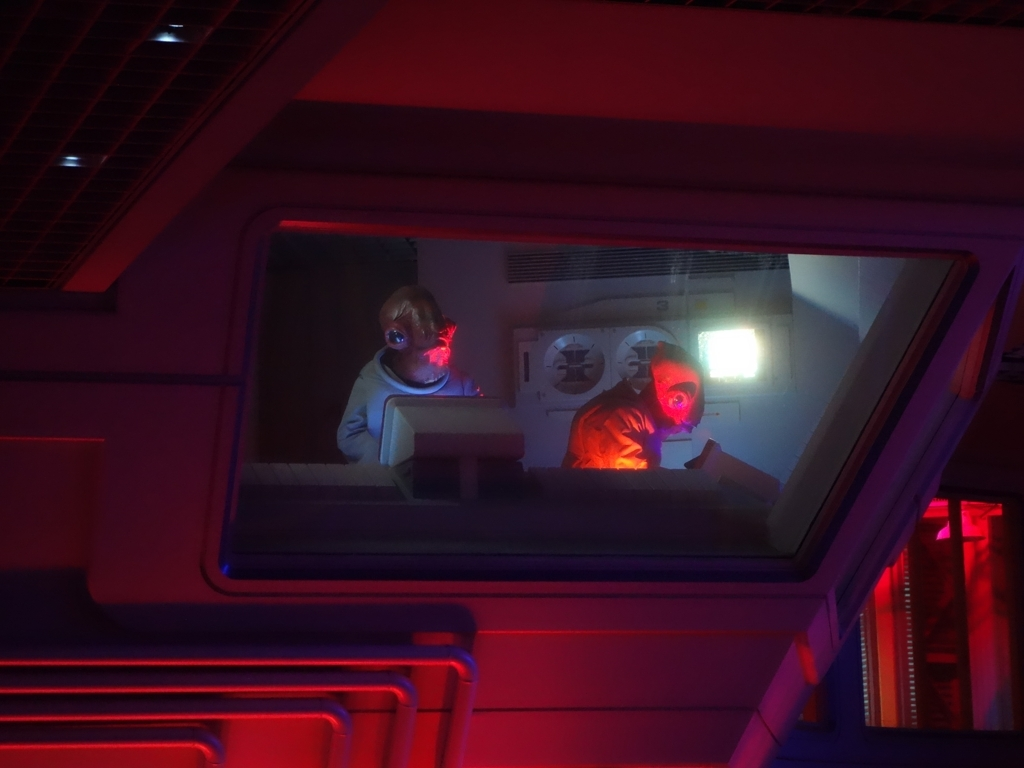What is happening in this image, and what might the red and blue lights signify? This image captures a scene with a strong narrative element. Two figures appear to be engaged in some technological or scientific activity, suggested by the computer-like screens and their focused attention. The red and blue lights typically signify contrasting temperatures, emotions, or factions, perhaps indicating a conflict or dichotomy within the narrative context, such as calm versus alarm, warm versus cold, or even opposing forces. Can you tell me more about the design style or era this image might represent? The design style of this image points towards a futuristic or sci-fi aesthetic, reminiscent of late 20th to early 21st-century works. The sleek, angular architecture, along with the modernistic technology, suggests a vision of the future. Elements such as the costumes of the figures and the industrial feel of the setting further enhance this impression, drawing from a rich tradition of science fiction set in space or technologically advanced societies. 